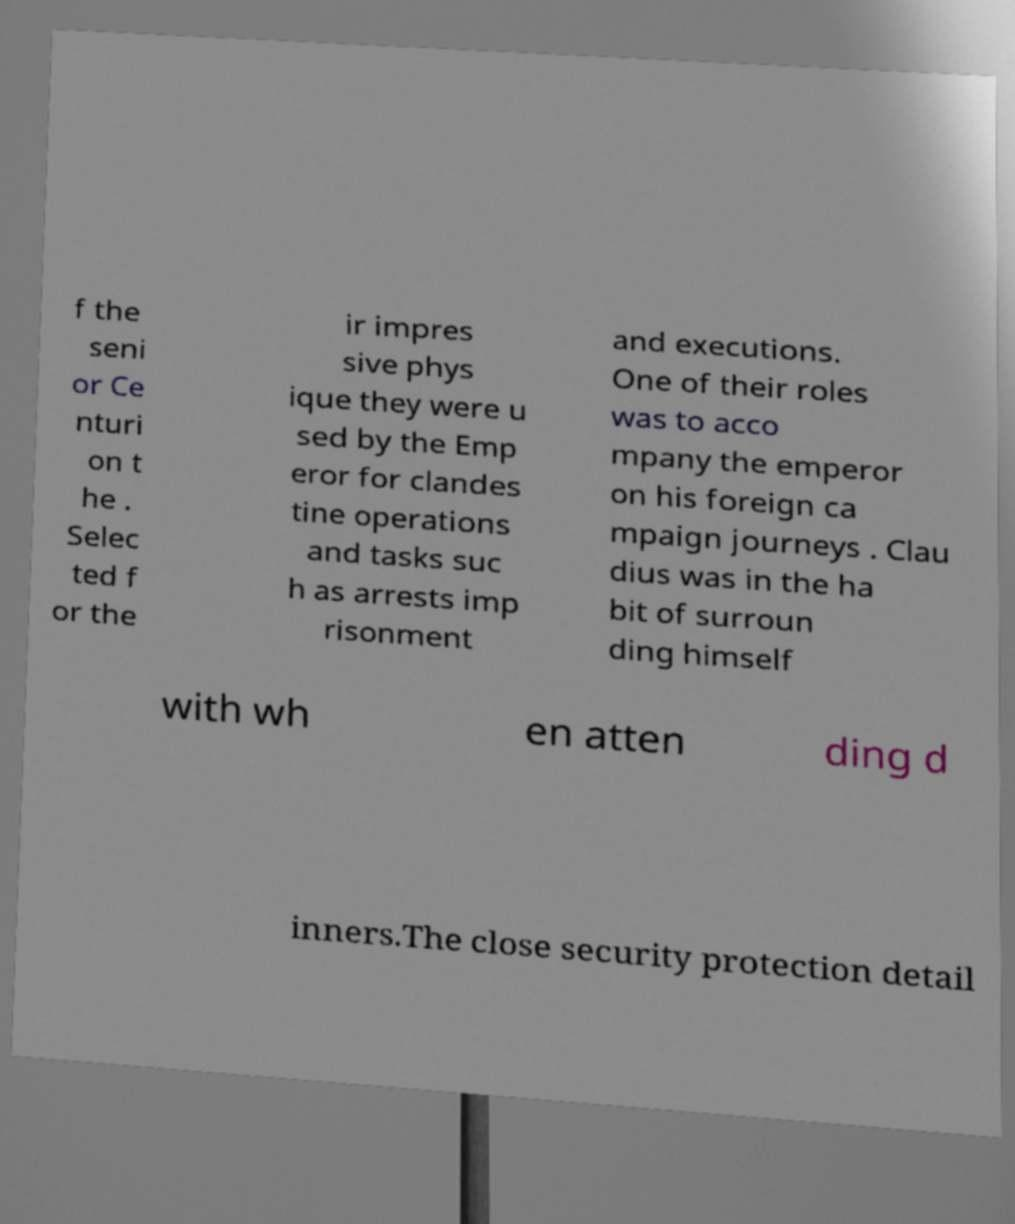Can you read and provide the text displayed in the image?This photo seems to have some interesting text. Can you extract and type it out for me? f the seni or Ce nturi on t he . Selec ted f or the ir impres sive phys ique they were u sed by the Emp eror for clandes tine operations and tasks suc h as arrests imp risonment and executions. One of their roles was to acco mpany the emperor on his foreign ca mpaign journeys . Clau dius was in the ha bit of surroun ding himself with wh en atten ding d inners.The close security protection detail 